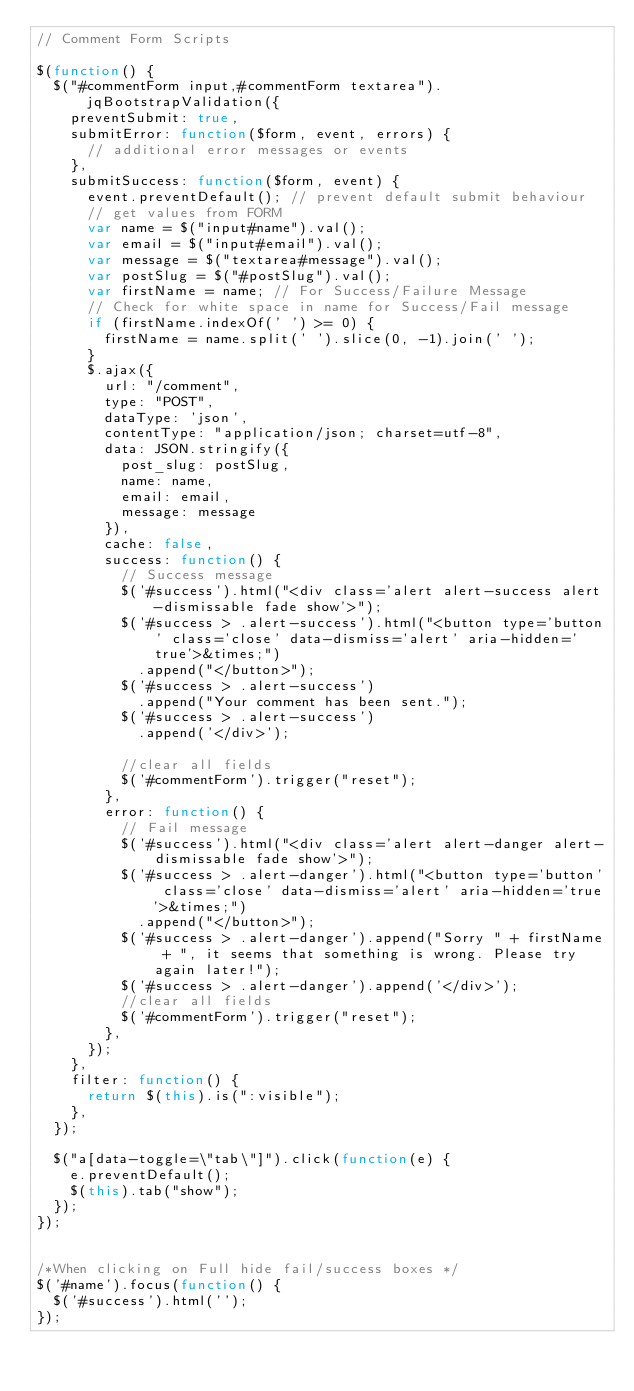Convert code to text. <code><loc_0><loc_0><loc_500><loc_500><_JavaScript_>// Comment Form Scripts

$(function() {
  $("#commentForm input,#commentForm textarea").jqBootstrapValidation({
    preventSubmit: true,
    submitError: function($form, event, errors) {
      // additional error messages or events
    },
    submitSuccess: function($form, event) {
      event.preventDefault(); // prevent default submit behaviour
      // get values from FORM
      var name = $("input#name").val();
      var email = $("input#email").val();
      var message = $("textarea#message").val();
      var postSlug = $("#postSlug").val();
      var firstName = name; // For Success/Failure Message
      // Check for white space in name for Success/Fail message
      if (firstName.indexOf(' ') >= 0) {
        firstName = name.split(' ').slice(0, -1).join(' ');
      }
      $.ajax({
        url: "/comment",
        type: "POST",
        dataType: 'json',
        contentType: "application/json; charset=utf-8",
        data: JSON.stringify({
          post_slug: postSlug,
          name: name,
          email: email,
          message: message
        }),
        cache: false,
        success: function() {
          // Success message
          $('#success').html("<div class='alert alert-success alert-dismissable fade show'>");
          $('#success > .alert-success').html("<button type='button' class='close' data-dismiss='alert' aria-hidden='true'>&times;")
            .append("</button>");
          $('#success > .alert-success')
            .append("Your comment has been sent.");
          $('#success > .alert-success')
            .append('</div>');

          //clear all fields
          $('#commentForm').trigger("reset");
        },
        error: function() {
          // Fail message
          $('#success').html("<div class='alert alert-danger alert-dismissable fade show'>");
          $('#success > .alert-danger').html("<button type='button' class='close' data-dismiss='alert' aria-hidden='true'>&times;")
            .append("</button>");
          $('#success > .alert-danger').append("Sorry " + firstName + ", it seems that something is wrong. Please try again later!");
          $('#success > .alert-danger').append('</div>');
          //clear all fields
          $('#commentForm').trigger("reset");
        },
      });
    },
    filter: function() {
      return $(this).is(":visible");
    },
  });

  $("a[data-toggle=\"tab\"]").click(function(e) {
    e.preventDefault();
    $(this).tab("show");
  });
});


/*When clicking on Full hide fail/success boxes */
$('#name').focus(function() {
  $('#success').html('');
});
</code> 